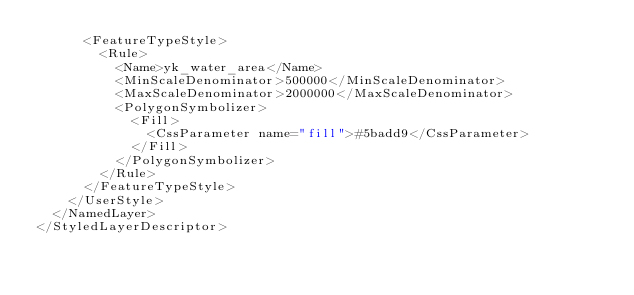<code> <loc_0><loc_0><loc_500><loc_500><_Scheme_>      <FeatureTypeStyle>
        <Rule>
          <Name>yk_water_area</Name>
          <MinScaleDenominator>500000</MinScaleDenominator>
          <MaxScaleDenominator>2000000</MaxScaleDenominator>
          <PolygonSymbolizer>
            <Fill>
              <CssParameter name="fill">#5badd9</CssParameter>
            </Fill>
          </PolygonSymbolizer>
        </Rule>
      </FeatureTypeStyle>
    </UserStyle>
  </NamedLayer>
</StyledLayerDescriptor>
</code> 